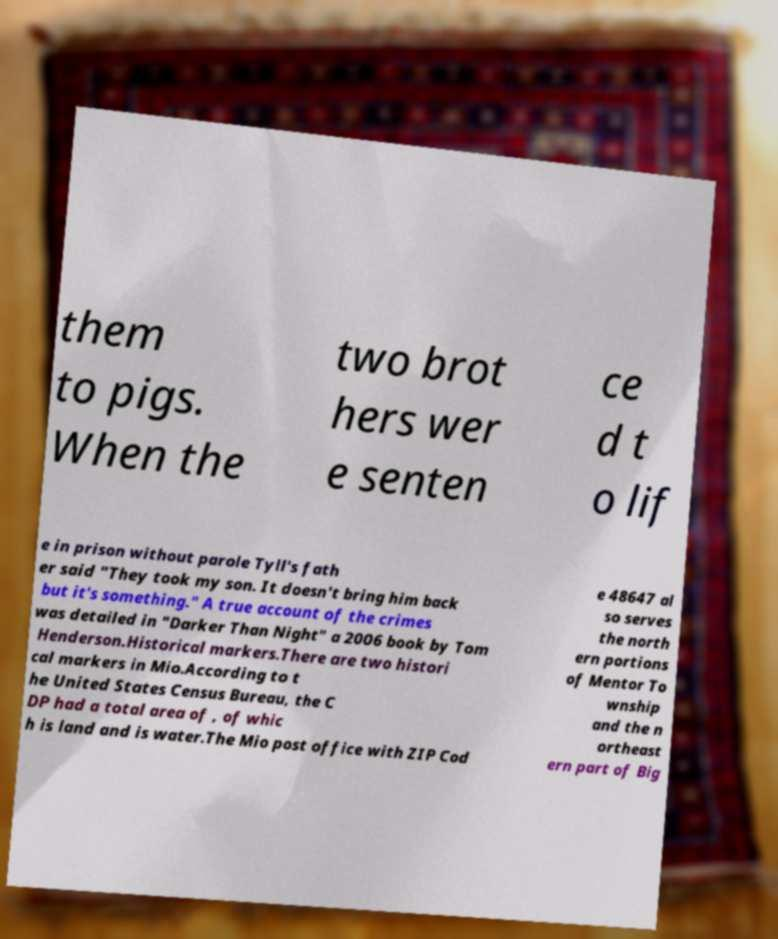Can you accurately transcribe the text from the provided image for me? them to pigs. When the two brot hers wer e senten ce d t o lif e in prison without parole Tyll's fath er said "They took my son. It doesn't bring him back but it's something." A true account of the crimes was detailed in "Darker Than Night" a 2006 book by Tom Henderson.Historical markers.There are two histori cal markers in Mio.According to t he United States Census Bureau, the C DP had a total area of , of whic h is land and is water.The Mio post office with ZIP Cod e 48647 al so serves the north ern portions of Mentor To wnship and the n ortheast ern part of Big 